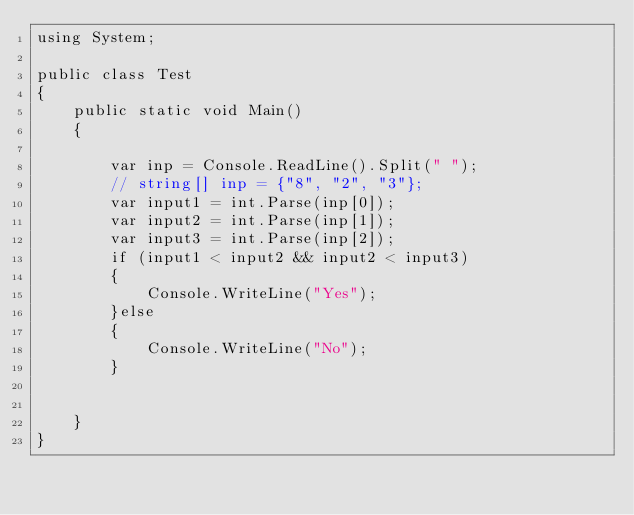<code> <loc_0><loc_0><loc_500><loc_500><_C#_>using System;

public class Test
{
    public static void Main()
    {

        var inp = Console.ReadLine().Split(" ");
        // string[] inp = {"8", "2", "3"}; 
        var input1 = int.Parse(inp[0]);
        var input2 = int.Parse(inp[1]);
        var input3 = int.Parse(inp[2]);
        if (input1 < input2 && input2 < input3)
        {
            Console.WriteLine("Yes");
        }else
        {
            Console.WriteLine("No");
        }


    }
}</code> 